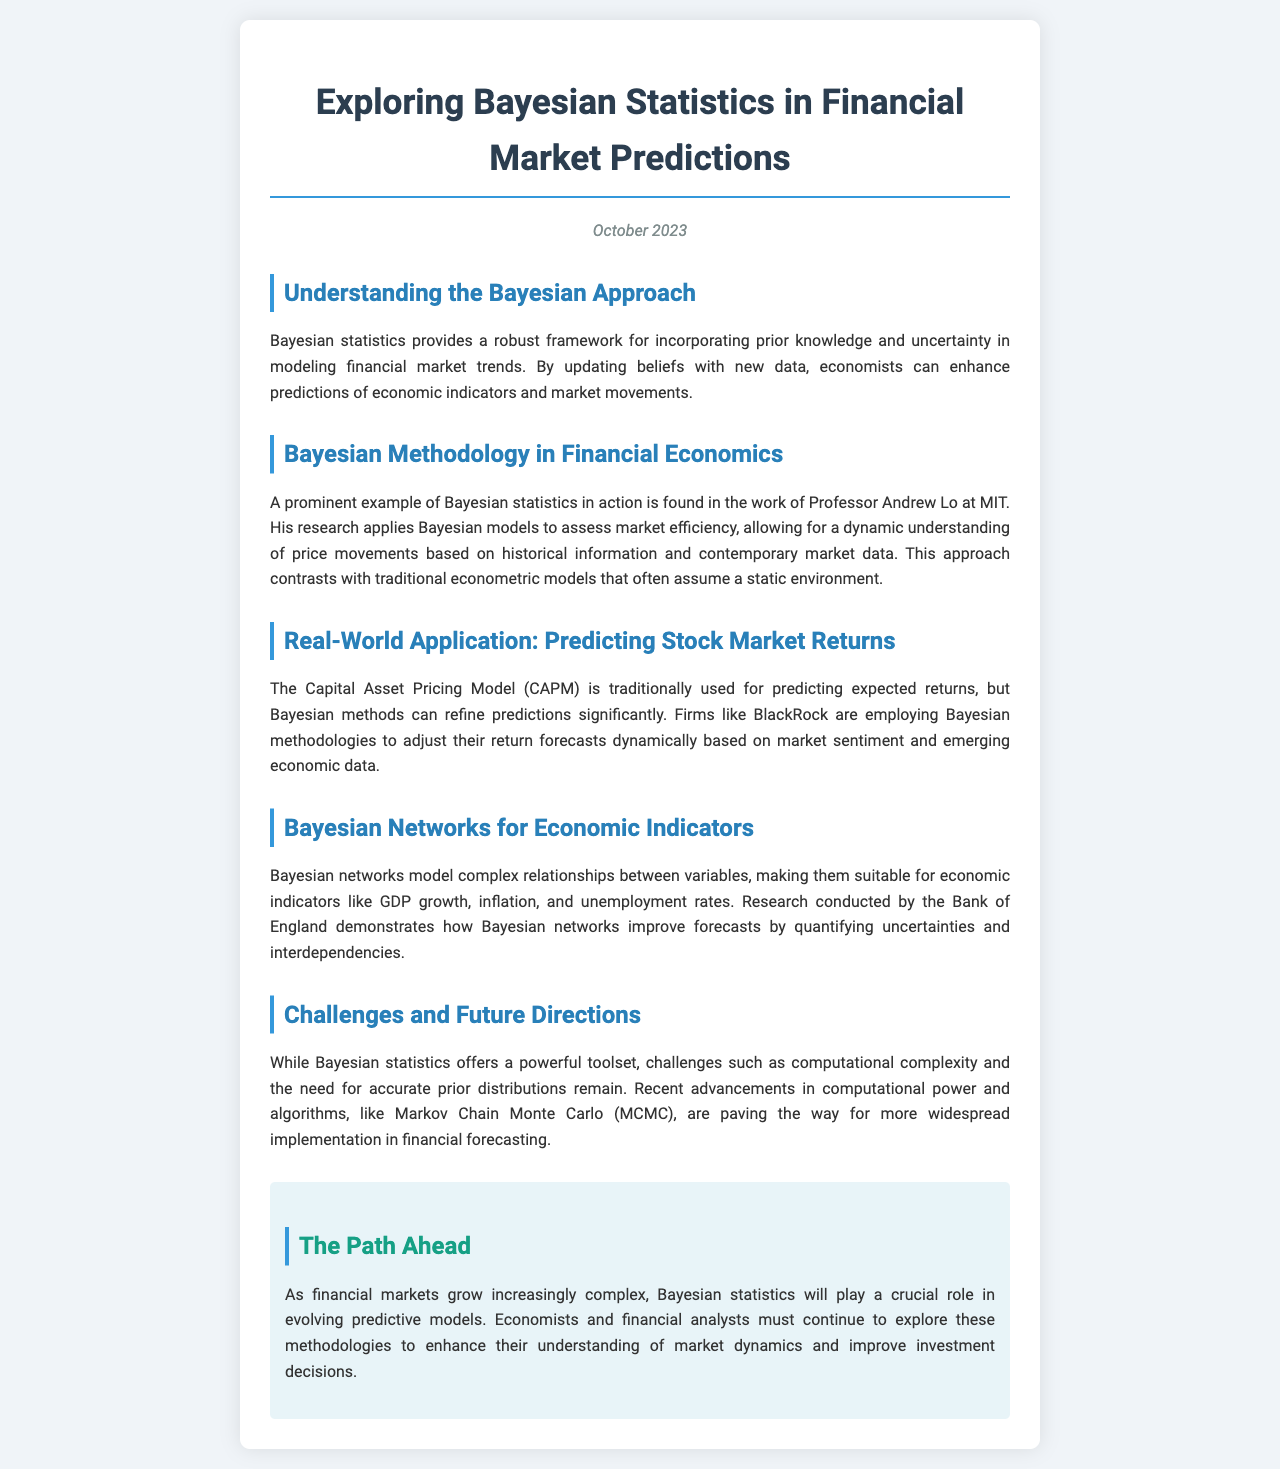What is the title of the newsletter? The title of the newsletter is located at the top of the document.
Answer: Exploring Bayesian Statistics in Financial Market Predictions Who is cited as a prominent researcher in the application of Bayesian models? The document mentions a specific researcher who applies Bayesian models to assess market efficiency.
Answer: Professor Andrew Lo Which model is discussed as a traditional method for predicting expected returns? The document references a specific predictive model often used in finance.
Answer: Capital Asset Pricing Model (CAPM) What issue does the document highlight as a challenge in Bayesian statistics? The newsletter lists specific challenges faced in the application of Bayesian statistics.
Answer: Computational complexity Which financial firm is mentioned as employing Bayesian methodologies? The document provides an example of a firm using Bayesian methods to adjust return forecasts.
Answer: BlackRock What research institution is noted for work on Bayesian networks? The newsletter references a specific institution that conducts research related to Bayesian networks for economic indicators.
Answer: Bank of England What recent advancements are noted as aiding Bayesian implementation? The document highlights advancements that facilitate the application of Bayesian statistics in financial forecasting.
Answer: Markov Chain Monte Carlo (MCMC) What is the publication date of the newsletter? The date is provided within the document, indicating when it was published.
Answer: October 2023 